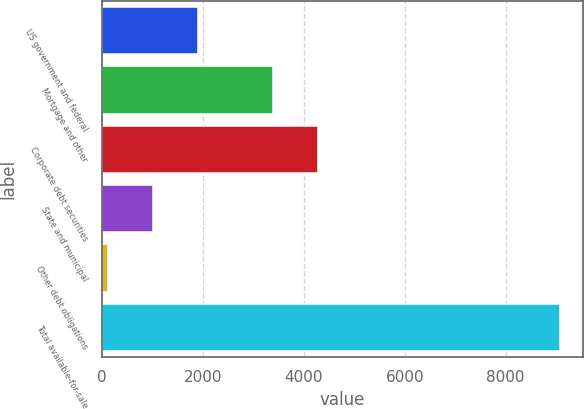<chart> <loc_0><loc_0><loc_500><loc_500><bar_chart><fcel>US government and federal<fcel>Mortgage and other<fcel>Corporate debt securities<fcel>State and municipal<fcel>Other debt obligations<fcel>Total available-for-sale<nl><fcel>1905.2<fcel>3382<fcel>4278.1<fcel>1009.1<fcel>113<fcel>9074<nl></chart> 